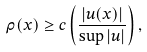Convert formula to latex. <formula><loc_0><loc_0><loc_500><loc_500>\rho ( x ) \geq c \left ( \frac { | u ( x ) | } { \sup | u | } \right ) ,</formula> 